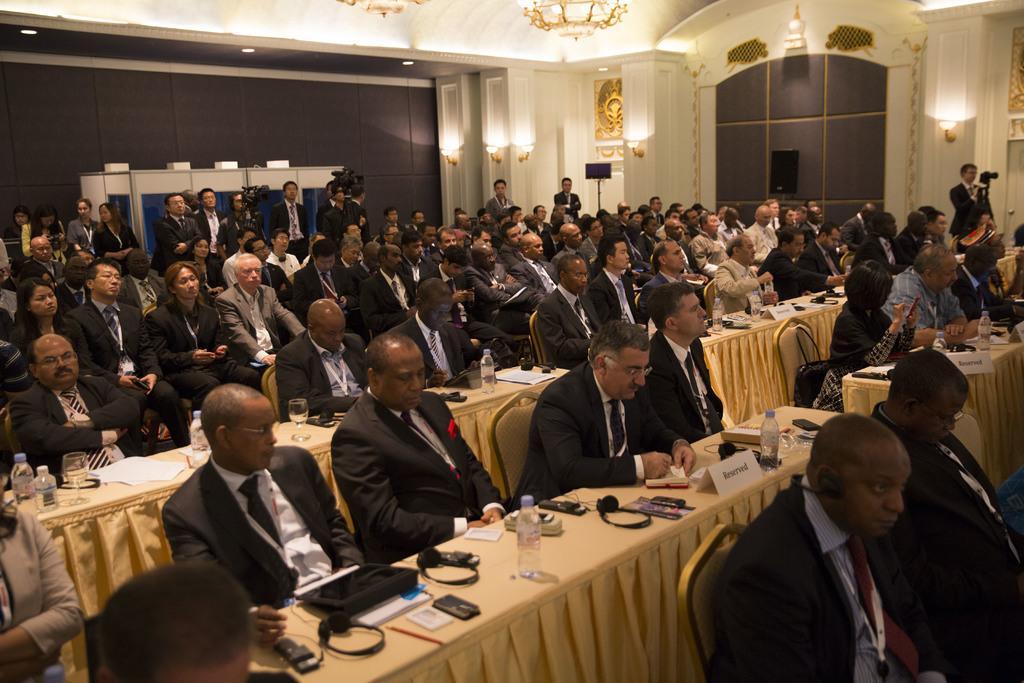How would you summarize this image in a sentence or two? In this picture we can see a group of people sitting on chairs and in front of them on table we have headsets, mobile, bottle, papers, pen, name board, glass and beside to them we can see window, lights, wall. 